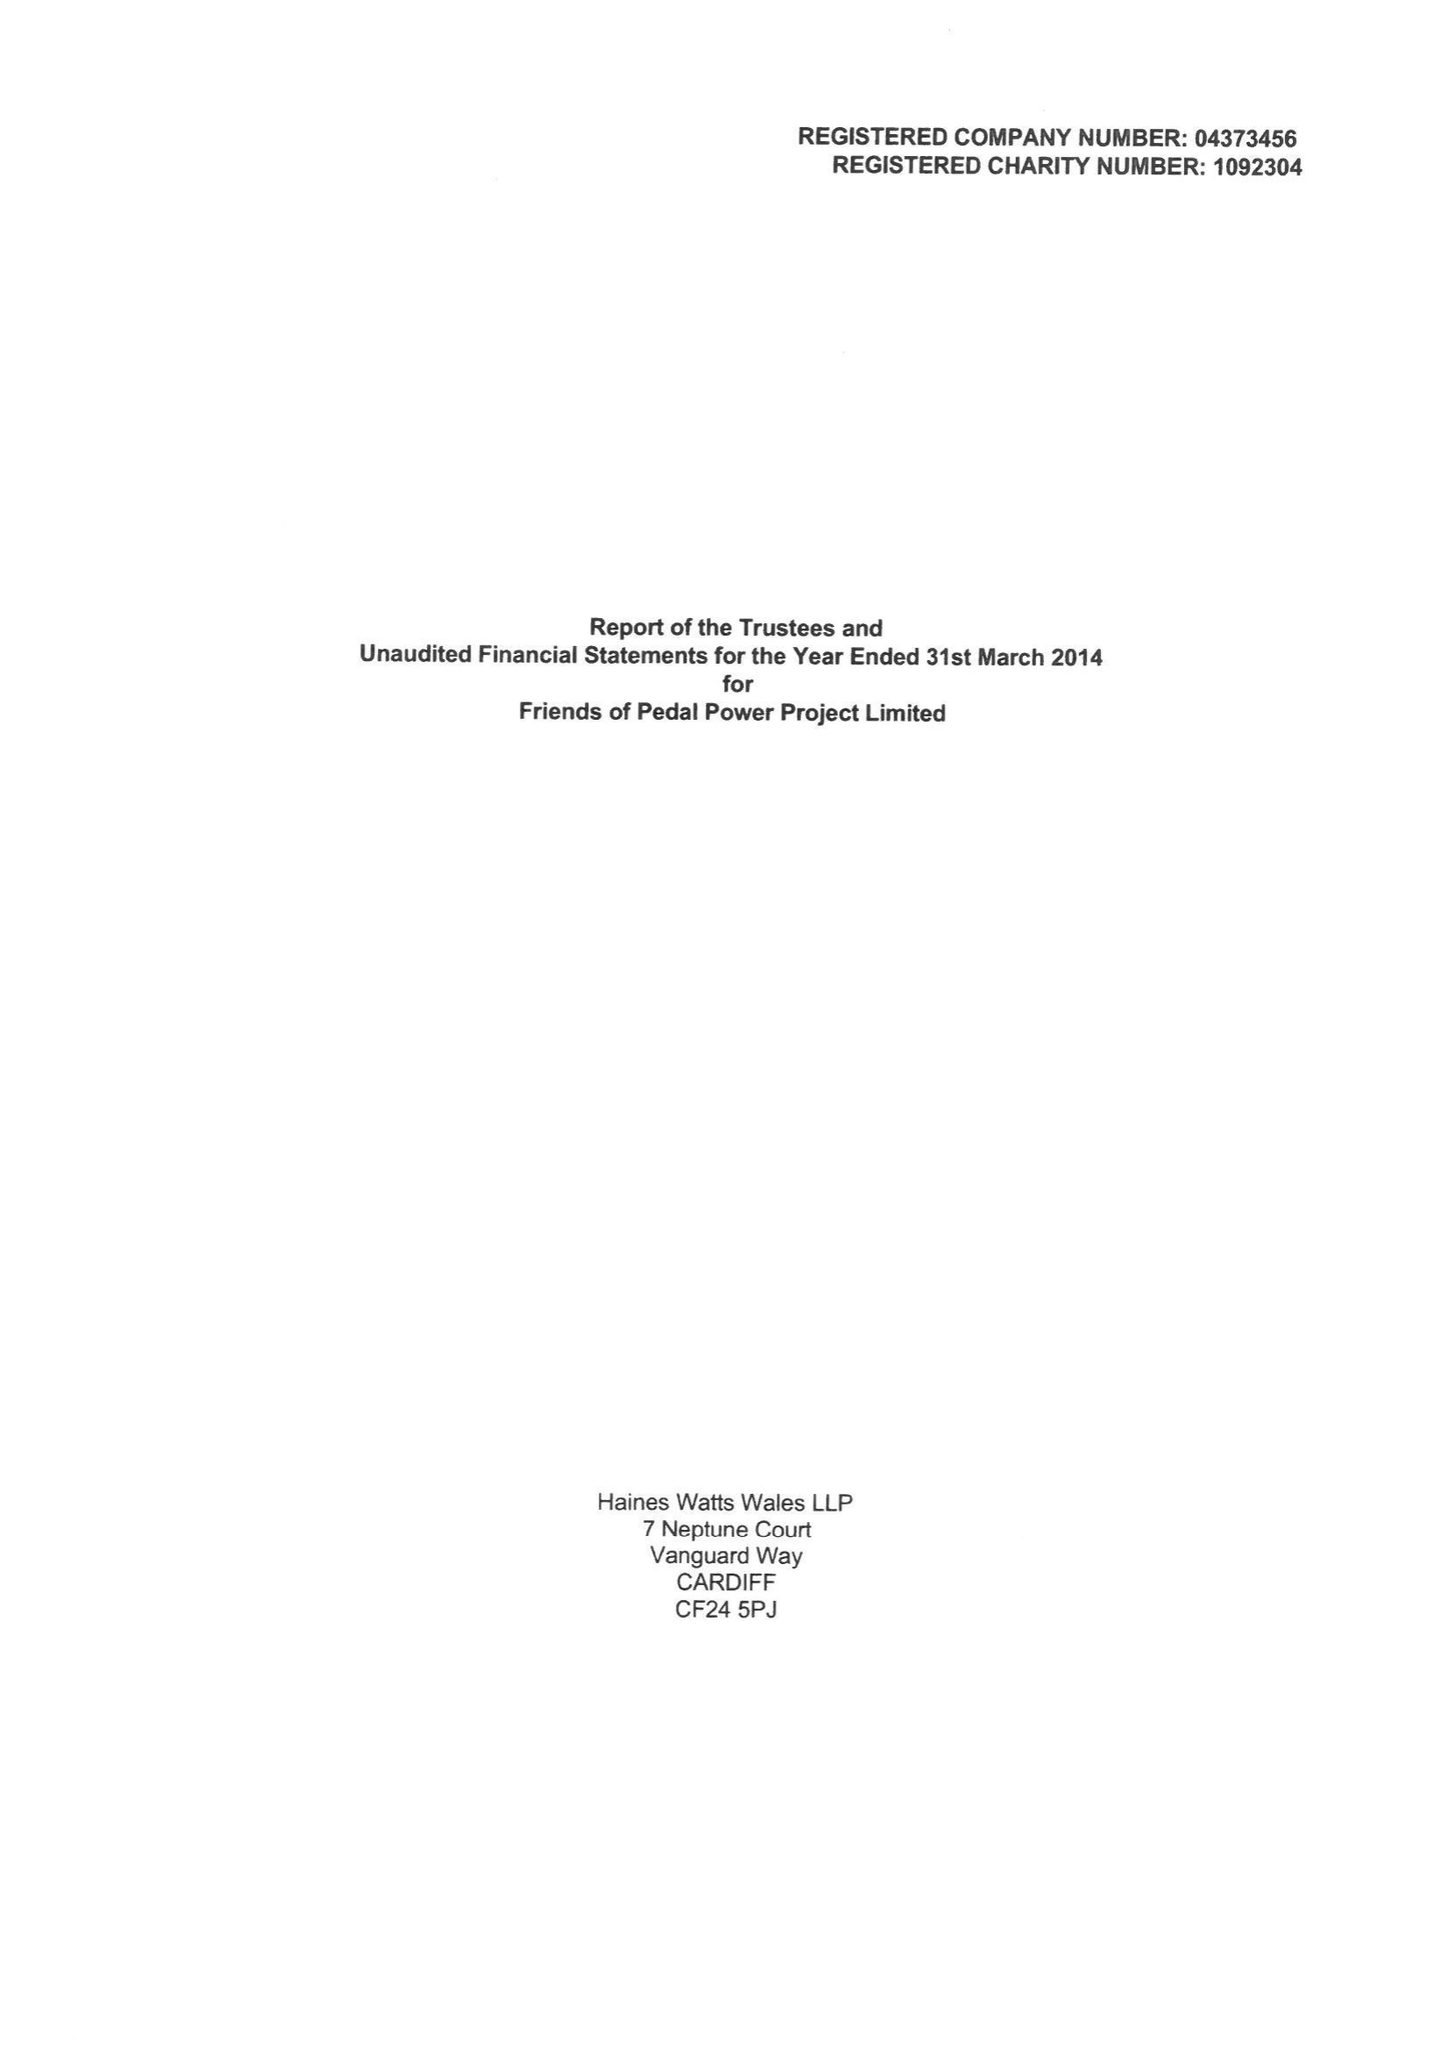What is the value for the address__street_line?
Answer the question using a single word or phrase. 105 PEARL STREET 